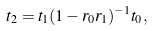Convert formula to latex. <formula><loc_0><loc_0><loc_500><loc_500>t _ { 2 } = t _ { 1 } ( 1 - r _ { 0 } r _ { 1 } ) ^ { - 1 } t _ { 0 } ,</formula> 